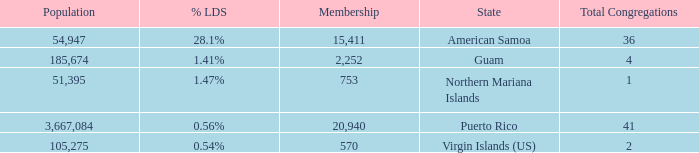What is the highest Population, when State is Puerto Rico, and when Total Congregations is greater than 41? None. 